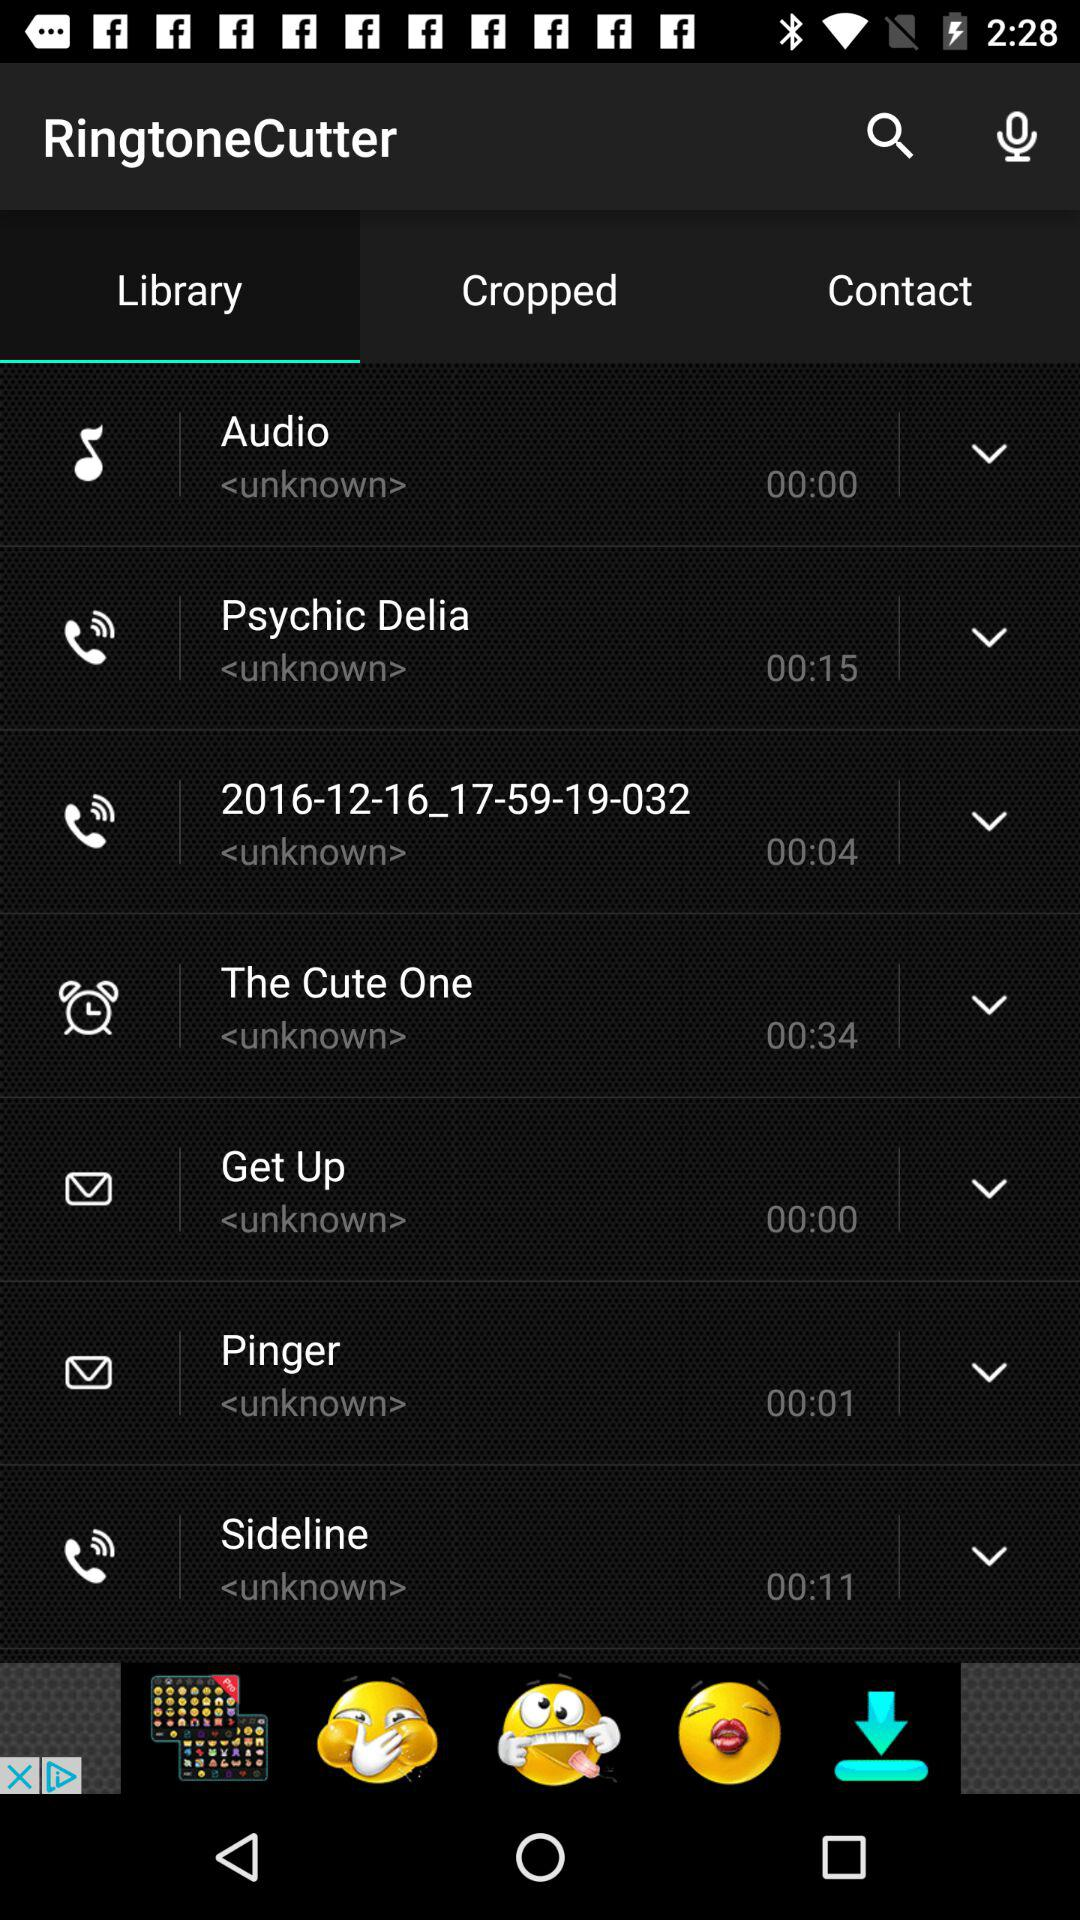What is the name of the application? The name of the application is "RingtoneCutter". 